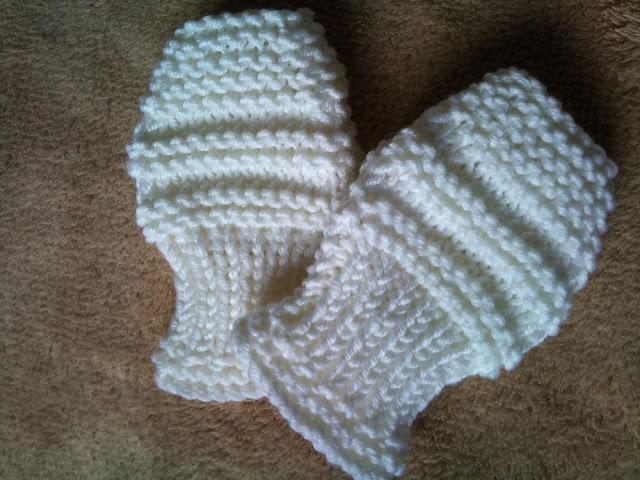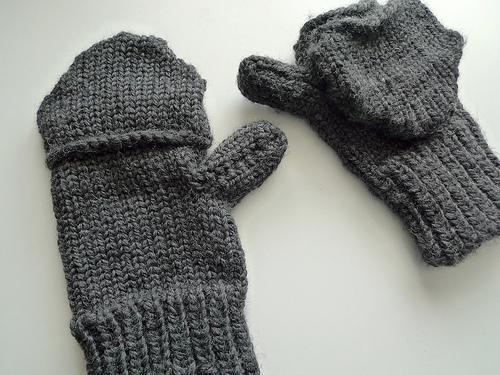The first image is the image on the left, the second image is the image on the right. Evaluate the accuracy of this statement regarding the images: "Both pairs of mittens are different shades of the same colors.". Is it true? Answer yes or no. No. 